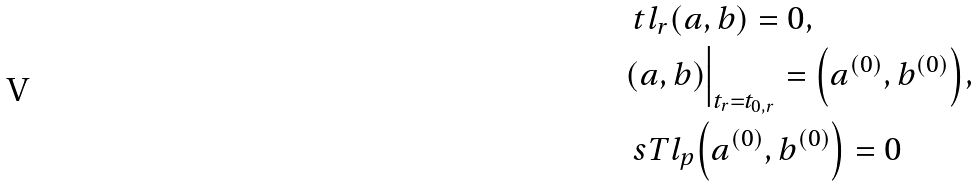Convert formula to latex. <formula><loc_0><loc_0><loc_500><loc_500>& \ t l _ { r } ( a , b ) = 0 , \\ & ( a , b ) \Big | _ { t _ { r } = t _ { 0 , r } } = \Big ( a ^ { ( 0 ) } , b ^ { ( 0 ) } \Big ) , \\ & \ s T l _ { p } \Big ( a ^ { ( 0 ) } , b ^ { ( 0 ) } \Big ) = 0</formula> 